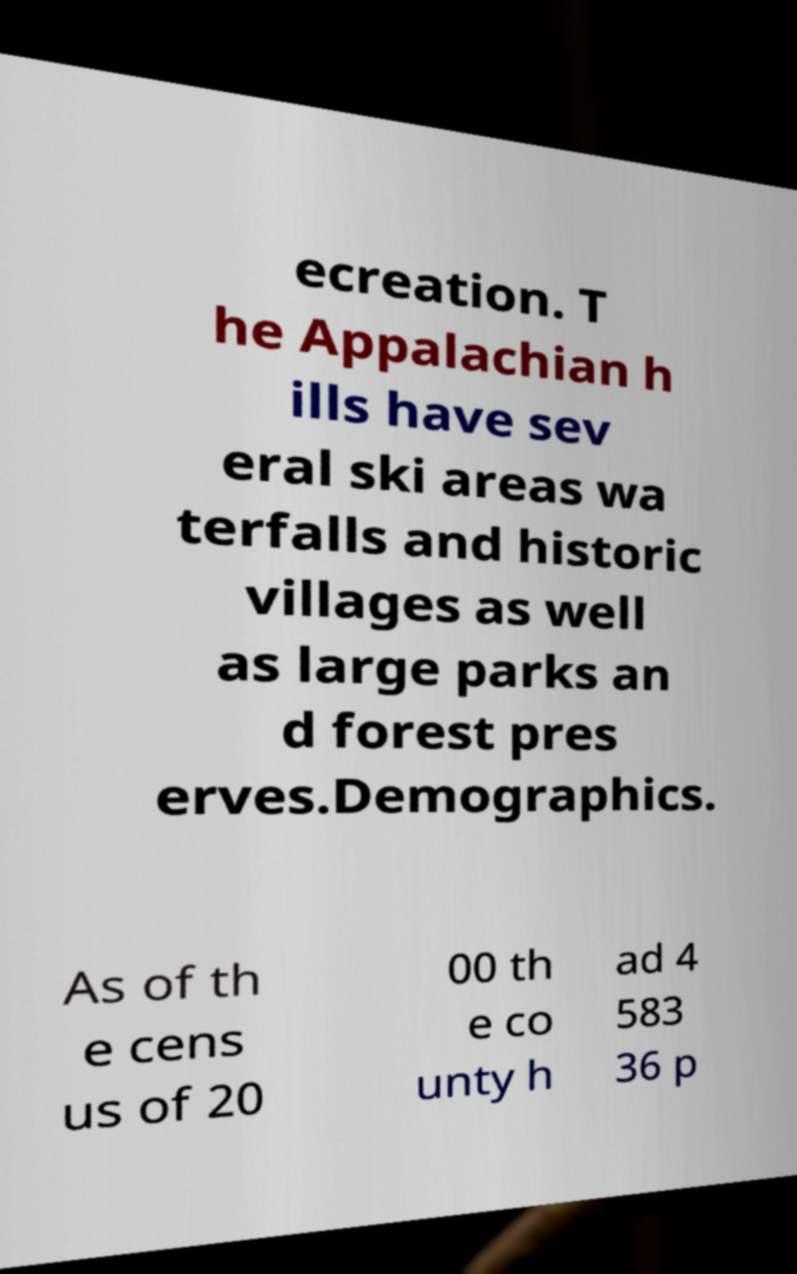For documentation purposes, I need the text within this image transcribed. Could you provide that? ecreation. T he Appalachian h ills have sev eral ski areas wa terfalls and historic villages as well as large parks an d forest pres erves.Demographics. As of th e cens us of 20 00 th e co unty h ad 4 583 36 p 